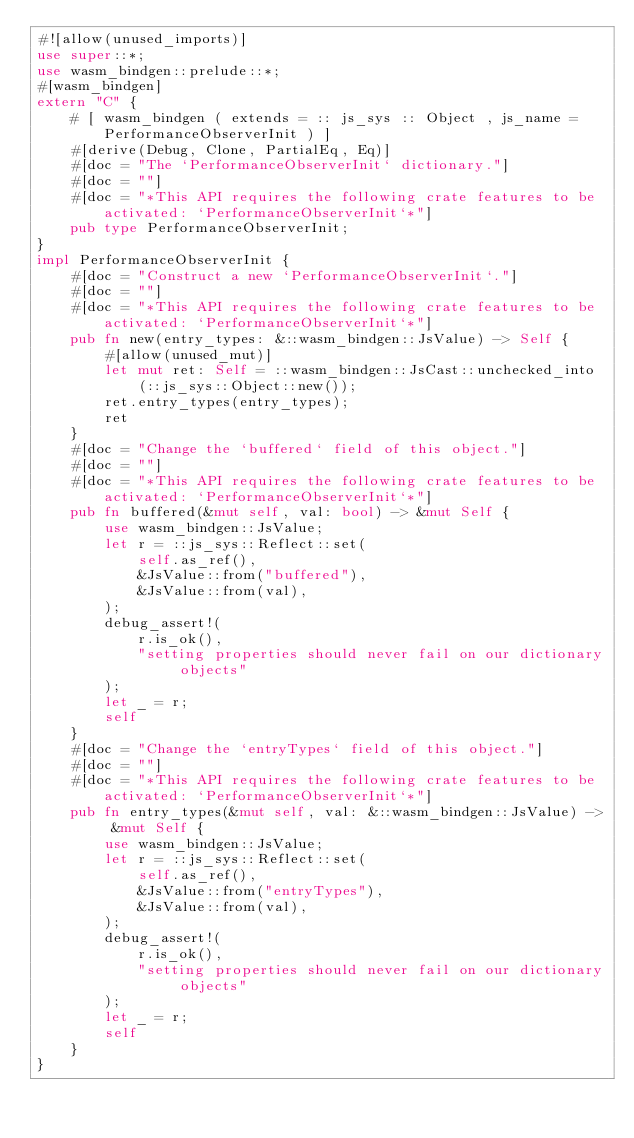<code> <loc_0><loc_0><loc_500><loc_500><_Rust_>#![allow(unused_imports)]
use super::*;
use wasm_bindgen::prelude::*;
#[wasm_bindgen]
extern "C" {
    # [ wasm_bindgen ( extends = :: js_sys :: Object , js_name = PerformanceObserverInit ) ]
    #[derive(Debug, Clone, PartialEq, Eq)]
    #[doc = "The `PerformanceObserverInit` dictionary."]
    #[doc = ""]
    #[doc = "*This API requires the following crate features to be activated: `PerformanceObserverInit`*"]
    pub type PerformanceObserverInit;
}
impl PerformanceObserverInit {
    #[doc = "Construct a new `PerformanceObserverInit`."]
    #[doc = ""]
    #[doc = "*This API requires the following crate features to be activated: `PerformanceObserverInit`*"]
    pub fn new(entry_types: &::wasm_bindgen::JsValue) -> Self {
        #[allow(unused_mut)]
        let mut ret: Self = ::wasm_bindgen::JsCast::unchecked_into(::js_sys::Object::new());
        ret.entry_types(entry_types);
        ret
    }
    #[doc = "Change the `buffered` field of this object."]
    #[doc = ""]
    #[doc = "*This API requires the following crate features to be activated: `PerformanceObserverInit`*"]
    pub fn buffered(&mut self, val: bool) -> &mut Self {
        use wasm_bindgen::JsValue;
        let r = ::js_sys::Reflect::set(
            self.as_ref(),
            &JsValue::from("buffered"),
            &JsValue::from(val),
        );
        debug_assert!(
            r.is_ok(),
            "setting properties should never fail on our dictionary objects"
        );
        let _ = r;
        self
    }
    #[doc = "Change the `entryTypes` field of this object."]
    #[doc = ""]
    #[doc = "*This API requires the following crate features to be activated: `PerformanceObserverInit`*"]
    pub fn entry_types(&mut self, val: &::wasm_bindgen::JsValue) -> &mut Self {
        use wasm_bindgen::JsValue;
        let r = ::js_sys::Reflect::set(
            self.as_ref(),
            &JsValue::from("entryTypes"),
            &JsValue::from(val),
        );
        debug_assert!(
            r.is_ok(),
            "setting properties should never fail on our dictionary objects"
        );
        let _ = r;
        self
    }
}
</code> 